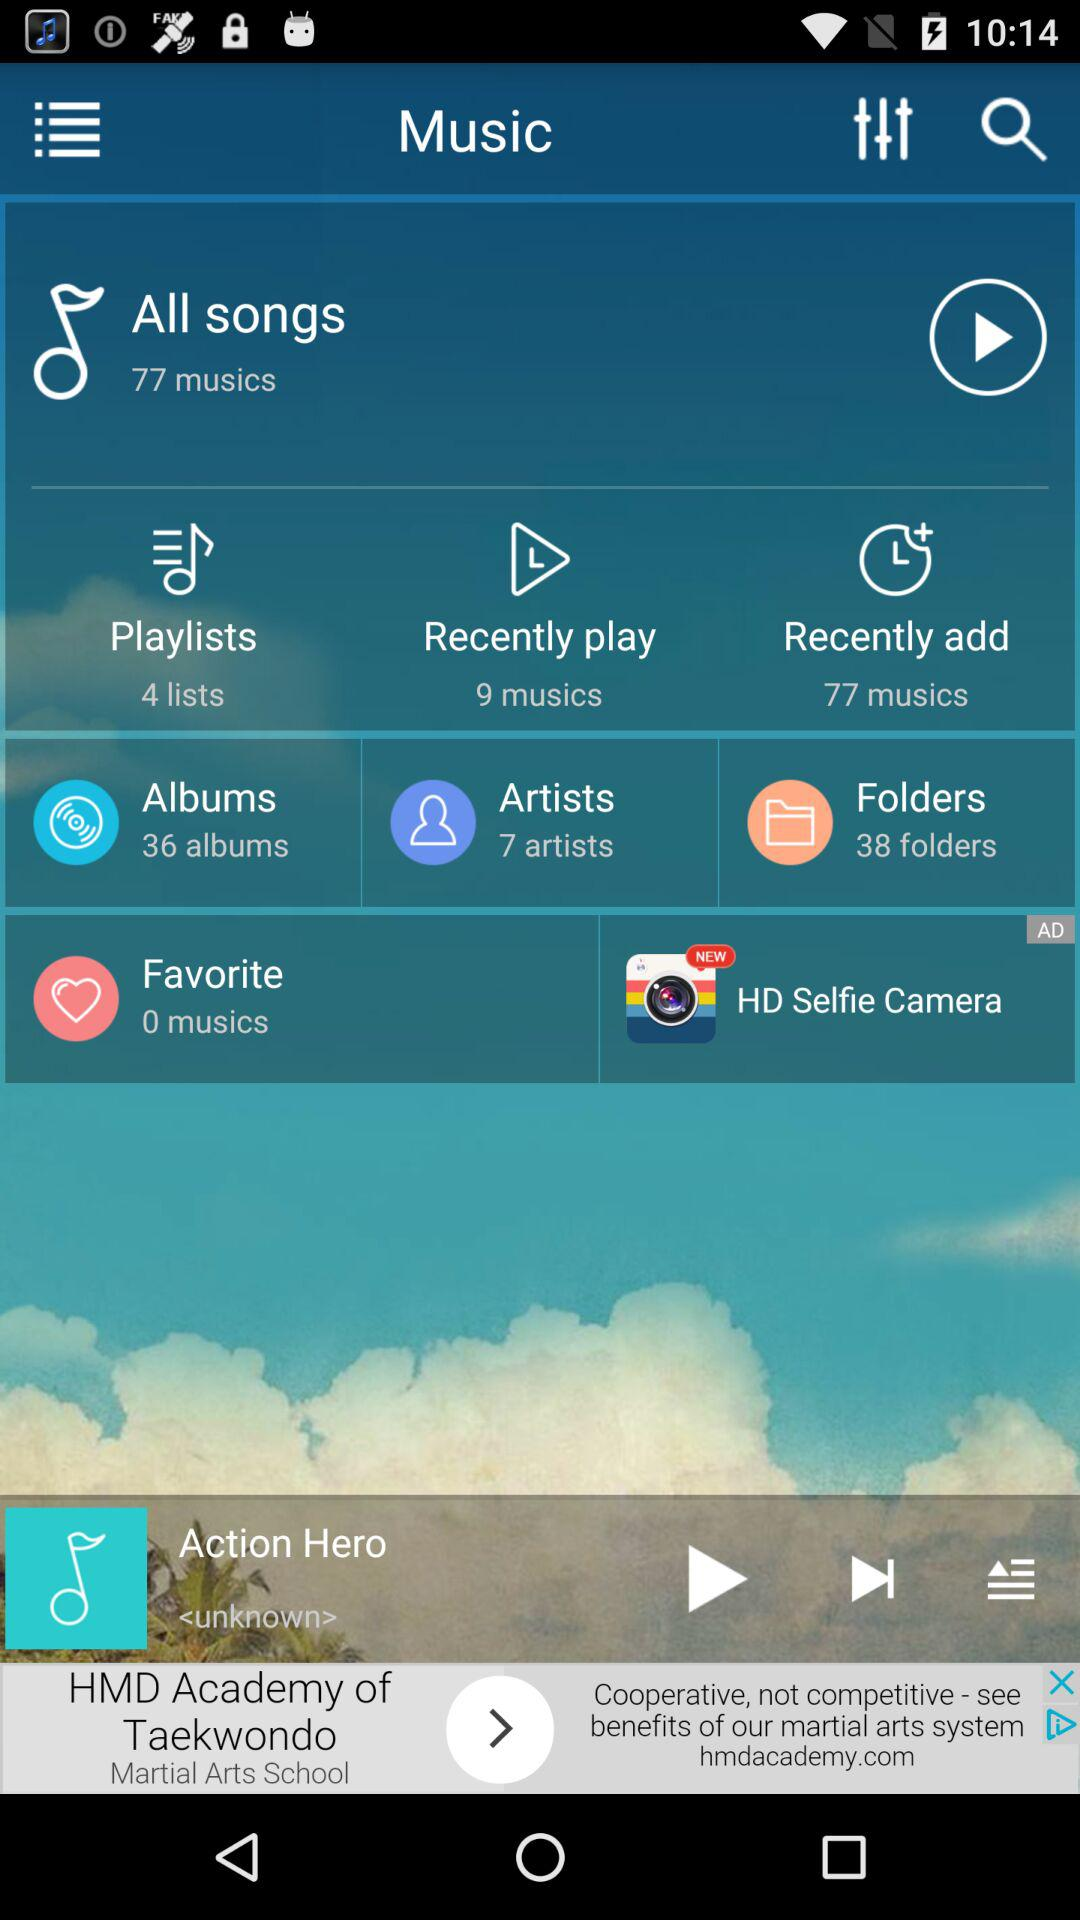How many artists are there? There are 7 artists. 